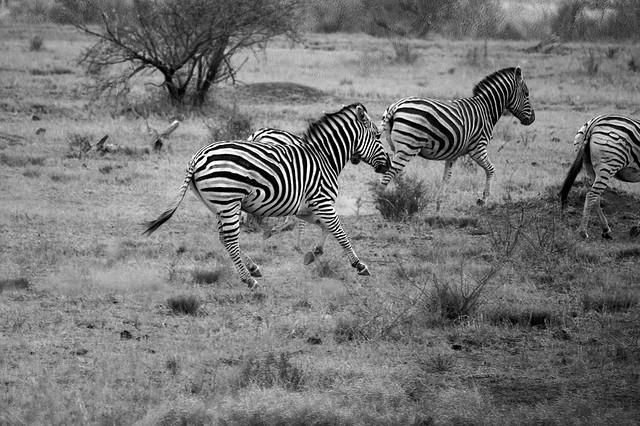How many zebras are running in the savannah area? four 